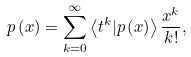Convert formula to latex. <formula><loc_0><loc_0><loc_500><loc_500>p \left ( x \right ) = \sum _ { k = 0 } ^ { \infty } \left \langle t ^ { k } | p \left ( x \right ) \right \rangle \frac { x ^ { k } } { k ! } ,</formula> 